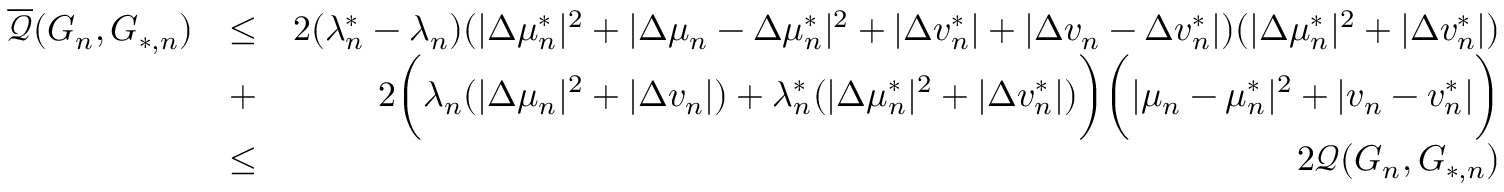Convert formula to latex. <formula><loc_0><loc_0><loc_500><loc_500>\begin{array} { r l r } { \overline { { \mathcal { Q } } } ( G _ { n } , G _ { * , n } ) } & { \leq } & { 2 ( \lambda _ { n } ^ { * } - \lambda _ { n } ) ( | \Delta \mu _ { n } ^ { * } | ^ { 2 } + | \Delta \mu _ { n } - \Delta \mu _ { n } ^ { * } | ^ { 2 } + | \Delta v _ { n } ^ { * } | + | \Delta v _ { n } - \Delta v _ { n } ^ { * } | ) ( | \Delta \mu _ { n } ^ { * } | ^ { 2 } + | \Delta v _ { n } ^ { * } | ) } \\ & { + } & { 2 \left ( \lambda _ { n } ( | \Delta \mu _ { n } | ^ { 2 } + | \Delta v _ { n } | ) + \lambda _ { n } ^ { * } ( | \Delta \mu _ { n } ^ { * } | ^ { 2 } + | \Delta v _ { n } ^ { * } | ) \right ) \left ( | \mu _ { n } - \mu _ { n } ^ { * } | ^ { 2 } + | v _ { n } - v _ { n } ^ { * } | \right ) } \\ & { \leq } & { 2 \mathcal { Q } ( G _ { n } , G _ { * , n } ) } \end{array}</formula> 